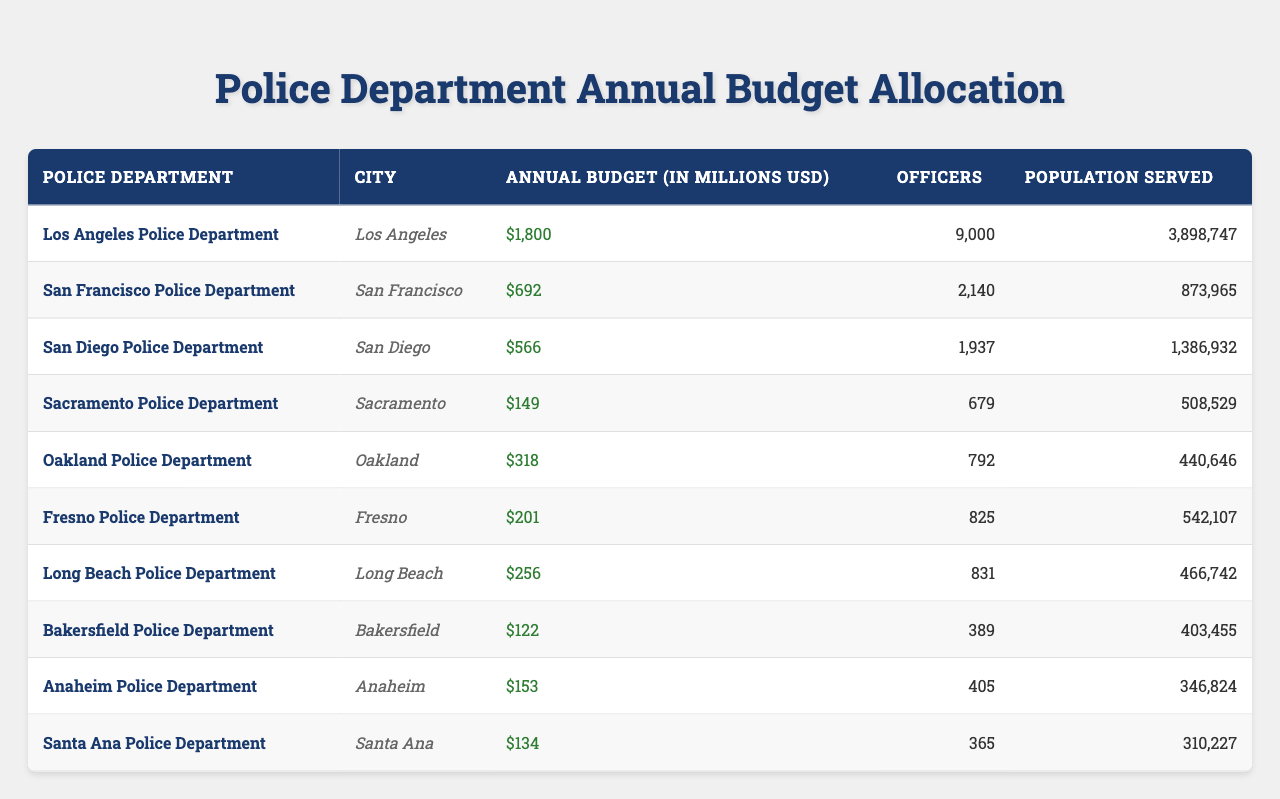What is the annual budget of the Los Angeles Police Department? The table shows that the annual budget for the Los Angeles Police Department is listed as 1800 million USD.
Answer: 1800 million USD Which police department has the smallest annual budget? Looking through the budgets listed, the Sacramento Police Department has the smallest budget at 149 million USD.
Answer: Sacramento Police Department How many officers does the San Francisco Police Department have? Referring to the table, it indicates that the San Francisco Police Department has 2140 officers.
Answer: 2140 officers What is the total annual budget allocated to Los Angeles, San Francisco, and San Diego police departments? The budgets for these departments are 1800 million, 692 million, and 566 million respectively. Adding them together: 1800 + 692 + 566 = 3058 million USD.
Answer: 3058 million USD How many officers serve the population in Fresno compared to the population served by the Oakland Police Department? Fresno serves a population of 542107 with 825 officers while Oakland serves 440646 with 792 officers.
Answer: Fresno has more officers per capita Is the population served by the Santa Ana Police Department larger than that served by the Long Beach Police Department? The population served by Santa Ana is 310227, and Long Beach serves 466742, therefore, Long Beach serves a larger population.
Answer: No What is the average budget allocation of the police departments listed? To calculate the average, first sum the budgets: 1800 + 692 + 566 + 149 + 318 + 201 + 256 + 122 + 153 + 134 = 4191 million USD, then divide by the number of departments (10), which gives 419.1 million USD.
Answer: 419.1 million USD Which police department has the highest budget and how does it compare to the department with the lowest budget? The Los Angeles Police Department has the highest budget of 1800 million USD, while the Sacramento Police Department has the lowest budget at 149 million USD. The difference between them is 1800 - 149 = 1651 million USD.
Answer: Los Angeles; 1651 million USD difference Are there more officers in the San Diego Police Department or the Oakland Police Department? The San Diego Police Department has 1937 officers while Oakland has 792. Since 1937 is greater than 792, San Diego has more officers.
Answer: San Diego Police Department has more officers What is the total population served by all the police departments combined? Adding the populations served: 3898747 + 873965 + 1386932 + 508529 + 440646 + 542107 + 466742 + 403455 + 346824 + 310227 gives a total of 7233574.
Answer: 7233574 